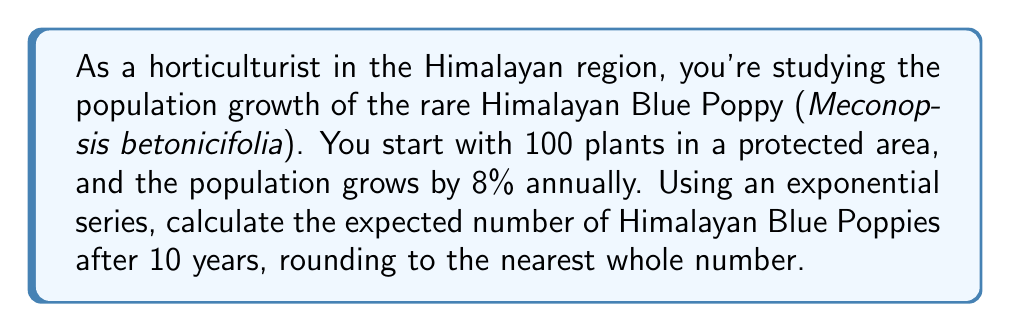Teach me how to tackle this problem. To solve this problem, we'll use the exponential growth formula:

$$P(t) = P_0 \cdot (1 + r)^t$$

Where:
$P(t)$ is the population at time $t$
$P_0$ is the initial population
$r$ is the growth rate
$t$ is the time in years

Given:
$P_0 = 100$ (initial population)
$r = 0.08$ (8% annual growth rate)
$t = 10$ years

Let's substitute these values into the formula:

$$P(10) = 100 \cdot (1 + 0.08)^{10}$$

Now, let's calculate step by step:

1) First, calculate $(1 + 0.08)^{10}$:
   $$(1.08)^{10} = 2.1589$$

2) Multiply this by the initial population:
   $$100 \cdot 2.1589 = 215.89$$

3) Round to the nearest whole number:
   $$215.89 \approx 216$$

Therefore, after 10 years, we expect approximately 216 Himalayan Blue Poppies in the protected area.
Answer: 216 Himalayan Blue Poppies 